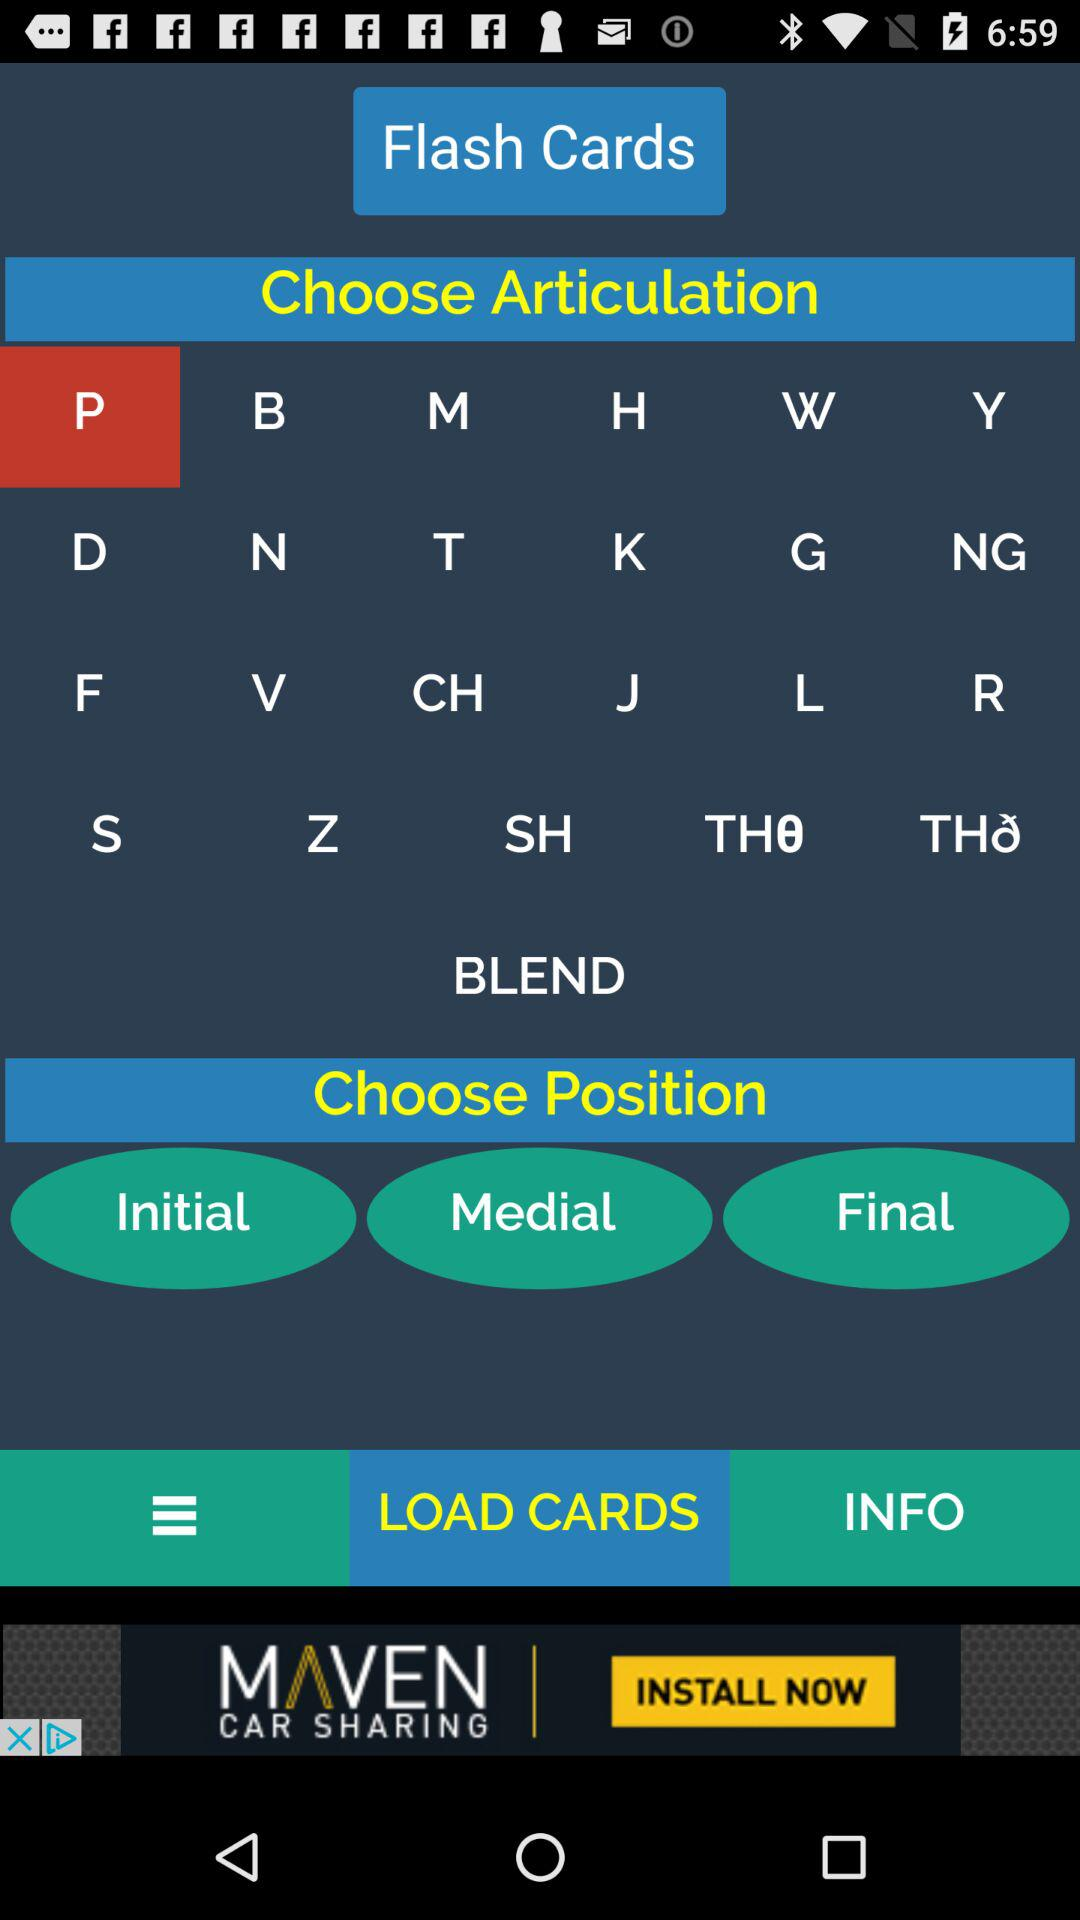What are the options for choosing the position? The options are "Initial", "Medial" and "Final". 